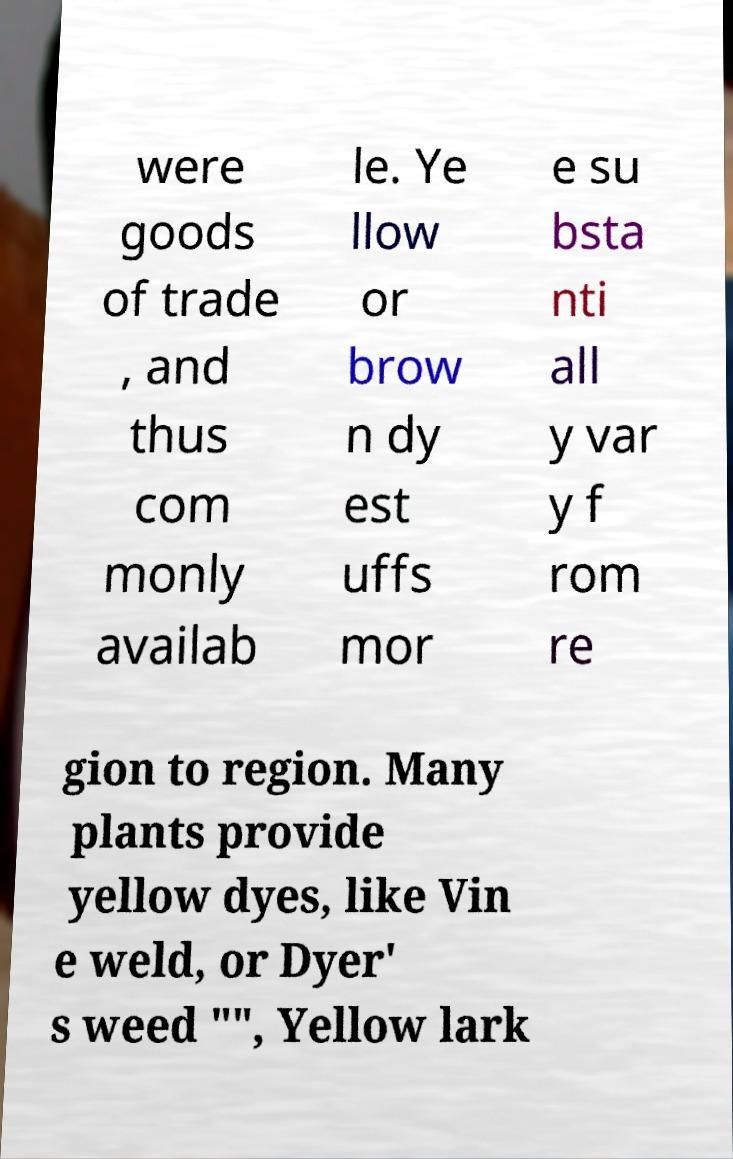Could you assist in decoding the text presented in this image and type it out clearly? were goods of trade , and thus com monly availab le. Ye llow or brow n dy est uffs mor e su bsta nti all y var y f rom re gion to region. Many plants provide yellow dyes, like Vin e weld, or Dyer' s weed "", Yellow lark 